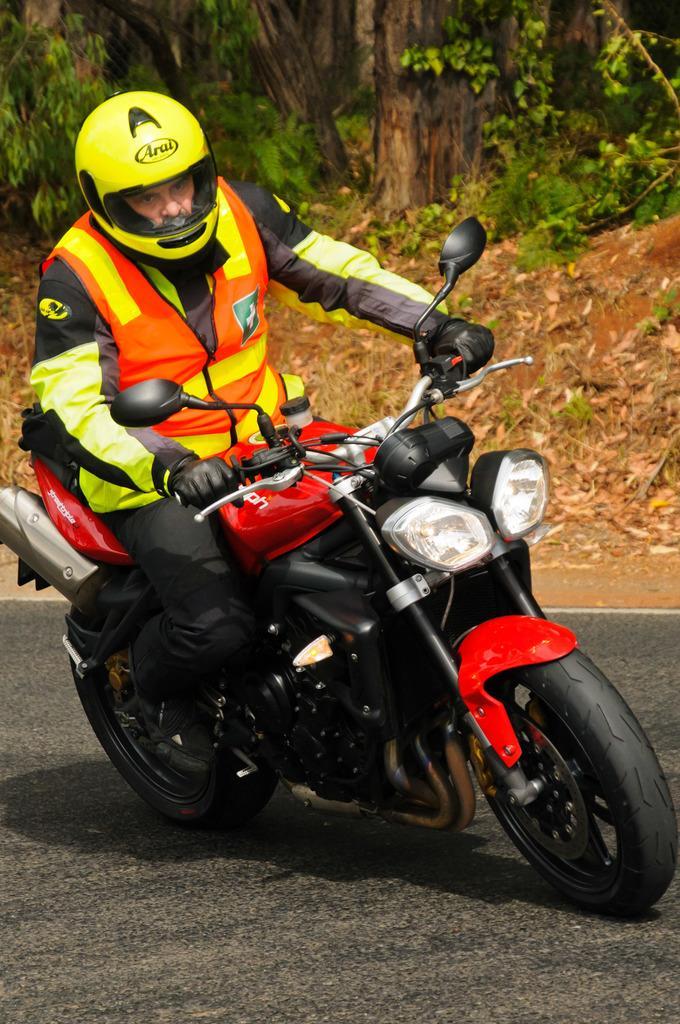How would you summarize this image in a sentence or two? In this image there are trees truncated, there are plants, there is a person wearing a helmet, there is a person wearing a helmet, there is a person riding a motorcycle. 